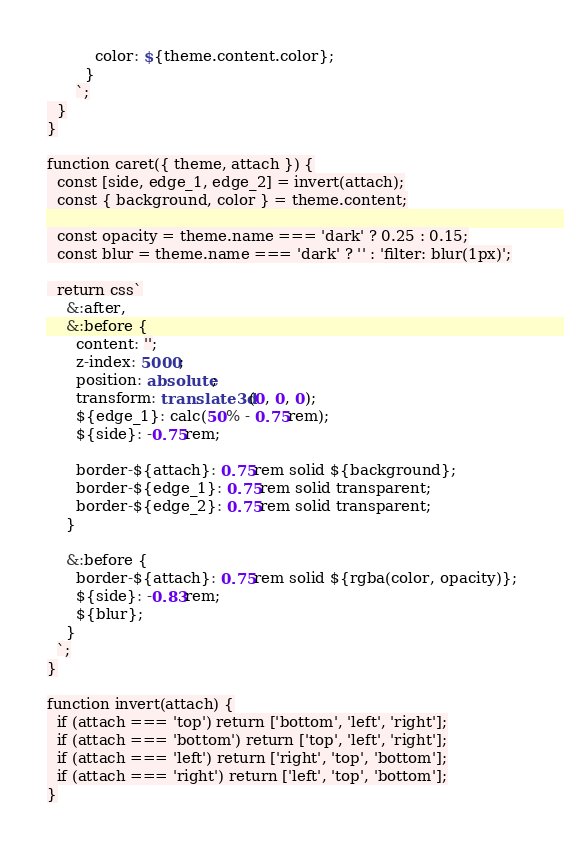Convert code to text. <code><loc_0><loc_0><loc_500><loc_500><_TypeScript_>          color: ${theme.content.color};
        }
      `;
  }
}

function caret({ theme, attach }) {
  const [side, edge_1, edge_2] = invert(attach);
  const { background, color } = theme.content;

  const opacity = theme.name === 'dark' ? 0.25 : 0.15;
  const blur = theme.name === 'dark' ? '' : 'filter: blur(1px)';

  return css`
    &:after,
    &:before {
      content: '';
      z-index: 5000;
      position: absolute;
      transform: translate3d(0, 0, 0);
      ${edge_1}: calc(50% - 0.75rem);
      ${side}: -0.75rem;

      border-${attach}: 0.75rem solid ${background};
      border-${edge_1}: 0.75rem solid transparent;
      border-${edge_2}: 0.75rem solid transparent;
    }

    &:before {
      border-${attach}: 0.75rem solid ${rgba(color, opacity)};
      ${side}: -0.83rem;
      ${blur};
    }
  `;
}

function invert(attach) {
  if (attach === 'top') return ['bottom', 'left', 'right'];
  if (attach === 'bottom') return ['top', 'left', 'right'];
  if (attach === 'left') return ['right', 'top', 'bottom'];
  if (attach === 'right') return ['left', 'top', 'bottom'];
}
</code> 